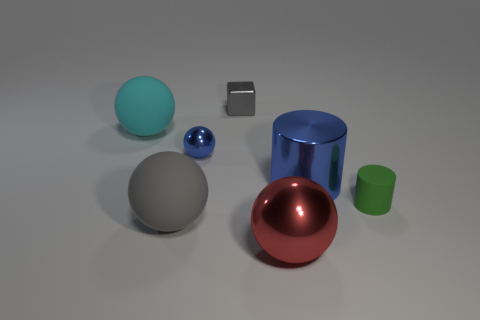How many big spheres are the same material as the small green cylinder?
Your response must be concise. 2. There is a gray object behind the tiny ball; what shape is it?
Provide a succinct answer. Cube. Are the tiny thing on the right side of the small gray thing and the gray object behind the tiny green cylinder made of the same material?
Your response must be concise. No. Are there any blue objects that have the same shape as the big cyan object?
Keep it short and to the point. Yes. What number of objects are small objects in front of the cyan matte sphere or cyan rubber objects?
Offer a terse response. 3. Is the number of tiny gray cubes that are in front of the gray shiny block greater than the number of cyan things in front of the red metal object?
Your response must be concise. No. What number of rubber objects are either balls or large red objects?
Ensure brevity in your answer.  2. There is a small object that is the same color as the shiny cylinder; what is its material?
Ensure brevity in your answer.  Metal. Is the number of gray matte objects that are behind the cyan rubber sphere less than the number of small gray metallic things that are right of the cube?
Give a very brief answer. No. What number of objects are either red cylinders or big things left of the blue metal cylinder?
Ensure brevity in your answer.  3. 